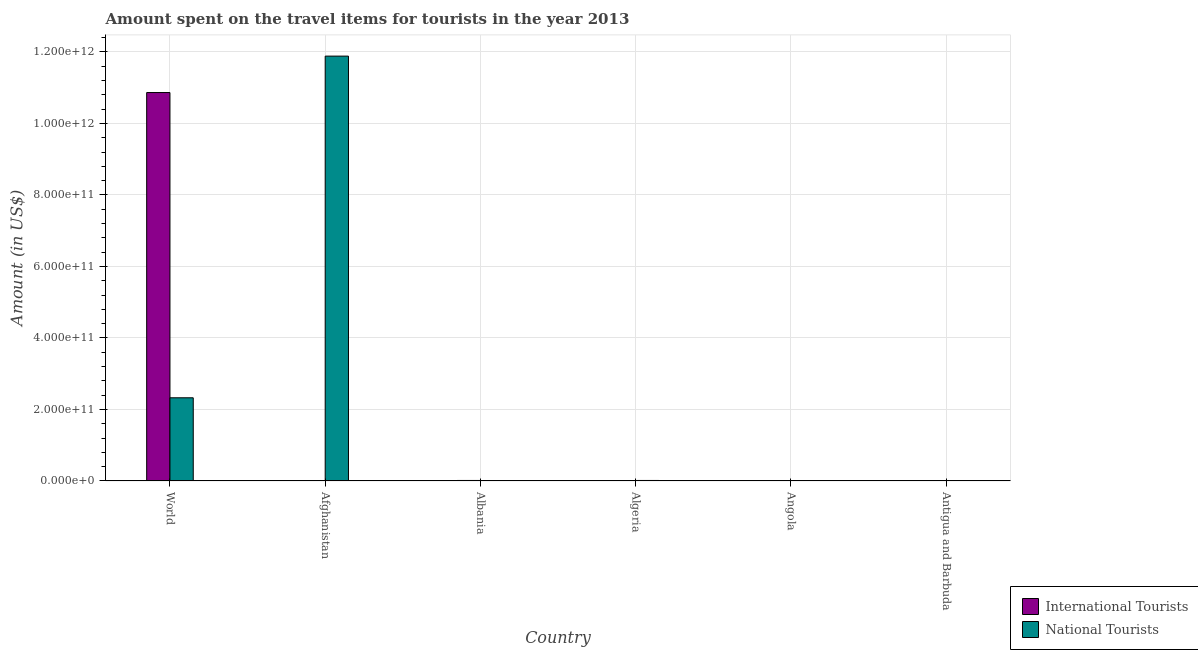How many different coloured bars are there?
Your answer should be compact. 2. How many groups of bars are there?
Offer a very short reply. 6. Are the number of bars per tick equal to the number of legend labels?
Keep it short and to the point. Yes. Are the number of bars on each tick of the X-axis equal?
Provide a succinct answer. Yes. How many bars are there on the 6th tick from the left?
Ensure brevity in your answer.  2. How many bars are there on the 5th tick from the right?
Keep it short and to the point. 2. What is the label of the 1st group of bars from the left?
Provide a succinct answer. World. In how many cases, is the number of bars for a given country not equal to the number of legend labels?
Ensure brevity in your answer.  0. What is the amount spent on travel items of national tourists in Antigua and Barbuda?
Offer a terse response. 1.23e+09. Across all countries, what is the maximum amount spent on travel items of national tourists?
Give a very brief answer. 1.19e+12. In which country was the amount spent on travel items of national tourists maximum?
Give a very brief answer. Afghanistan. In which country was the amount spent on travel items of international tourists minimum?
Your answer should be compact. Antigua and Barbuda. What is the total amount spent on travel items of international tourists in the graph?
Your response must be concise. 1.09e+12. What is the difference between the amount spent on travel items of national tourists in Algeria and that in World?
Provide a succinct answer. -2.31e+11. What is the difference between the amount spent on travel items of international tourists in Afghanistan and the amount spent on travel items of national tourists in Angola?
Keep it short and to the point. -1.56e+08. What is the average amount spent on travel items of international tourists per country?
Your response must be concise. 1.81e+11. What is the difference between the amount spent on travel items of international tourists and amount spent on travel items of national tourists in Algeria?
Provide a succinct answer. -1.05e+09. What is the ratio of the amount spent on travel items of international tourists in Albania to that in Antigua and Barbuda?
Offer a terse response. 29.58. Is the difference between the amount spent on travel items of international tourists in Algeria and Angola greater than the difference between the amount spent on travel items of national tourists in Algeria and Angola?
Offer a terse response. No. What is the difference between the highest and the second highest amount spent on travel items of international tourists?
Your answer should be very brief. 1.08e+12. What is the difference between the highest and the lowest amount spent on travel items of national tourists?
Provide a short and direct response. 1.19e+12. In how many countries, is the amount spent on travel items of international tourists greater than the average amount spent on travel items of international tourists taken over all countries?
Offer a terse response. 1. Is the sum of the amount spent on travel items of international tourists in Afghanistan and Antigua and Barbuda greater than the maximum amount spent on travel items of national tourists across all countries?
Your response must be concise. No. What does the 2nd bar from the left in Afghanistan represents?
Make the answer very short. National Tourists. What does the 1st bar from the right in Antigua and Barbuda represents?
Your response must be concise. National Tourists. How many bars are there?
Keep it short and to the point. 12. What is the difference between two consecutive major ticks on the Y-axis?
Give a very brief answer. 2.00e+11. Are the values on the major ticks of Y-axis written in scientific E-notation?
Keep it short and to the point. Yes. Does the graph contain grids?
Provide a succinct answer. Yes. What is the title of the graph?
Provide a succinct answer. Amount spent on the travel items for tourists in the year 2013. What is the Amount (in US$) in International Tourists in World?
Offer a very short reply. 1.09e+12. What is the Amount (in US$) of National Tourists in World?
Your response must be concise. 2.33e+11. What is the Amount (in US$) of International Tourists in Afghanistan?
Offer a very short reply. 9.40e+07. What is the Amount (in US$) of National Tourists in Afghanistan?
Make the answer very short. 1.19e+12. What is the Amount (in US$) in International Tourists in Albania?
Offer a very short reply. 1.48e+09. What is the Amount (in US$) of National Tourists in Albania?
Provide a succinct answer. 5.60e+07. What is the Amount (in US$) of International Tourists in Algeria?
Provide a short and direct response. 4.22e+08. What is the Amount (in US$) of National Tourists in Algeria?
Your response must be concise. 1.47e+09. What is the Amount (in US$) of International Tourists in Angola?
Your response must be concise. 1.66e+08. What is the Amount (in US$) in National Tourists in Angola?
Provide a short and direct response. 2.50e+08. What is the Amount (in US$) of International Tourists in Antigua and Barbuda?
Your answer should be compact. 5.00e+07. What is the Amount (in US$) of National Tourists in Antigua and Barbuda?
Make the answer very short. 1.23e+09. Across all countries, what is the maximum Amount (in US$) in International Tourists?
Keep it short and to the point. 1.09e+12. Across all countries, what is the maximum Amount (in US$) in National Tourists?
Your answer should be compact. 1.19e+12. Across all countries, what is the minimum Amount (in US$) of National Tourists?
Provide a succinct answer. 5.60e+07. What is the total Amount (in US$) of International Tourists in the graph?
Ensure brevity in your answer.  1.09e+12. What is the total Amount (in US$) of National Tourists in the graph?
Your response must be concise. 1.42e+12. What is the difference between the Amount (in US$) of International Tourists in World and that in Afghanistan?
Your answer should be very brief. 1.09e+12. What is the difference between the Amount (in US$) of National Tourists in World and that in Afghanistan?
Ensure brevity in your answer.  -9.56e+11. What is the difference between the Amount (in US$) in International Tourists in World and that in Albania?
Provide a short and direct response. 1.08e+12. What is the difference between the Amount (in US$) in National Tourists in World and that in Albania?
Offer a terse response. 2.33e+11. What is the difference between the Amount (in US$) in International Tourists in World and that in Algeria?
Keep it short and to the point. 1.09e+12. What is the difference between the Amount (in US$) in National Tourists in World and that in Algeria?
Offer a terse response. 2.31e+11. What is the difference between the Amount (in US$) in International Tourists in World and that in Angola?
Your answer should be very brief. 1.09e+12. What is the difference between the Amount (in US$) in National Tourists in World and that in Angola?
Offer a very short reply. 2.32e+11. What is the difference between the Amount (in US$) of International Tourists in World and that in Antigua and Barbuda?
Offer a terse response. 1.09e+12. What is the difference between the Amount (in US$) of National Tourists in World and that in Antigua and Barbuda?
Provide a short and direct response. 2.31e+11. What is the difference between the Amount (in US$) in International Tourists in Afghanistan and that in Albania?
Provide a short and direct response. -1.38e+09. What is the difference between the Amount (in US$) in National Tourists in Afghanistan and that in Albania?
Provide a succinct answer. 1.19e+12. What is the difference between the Amount (in US$) of International Tourists in Afghanistan and that in Algeria?
Give a very brief answer. -3.28e+08. What is the difference between the Amount (in US$) in National Tourists in Afghanistan and that in Algeria?
Your response must be concise. 1.19e+12. What is the difference between the Amount (in US$) in International Tourists in Afghanistan and that in Angola?
Make the answer very short. -7.20e+07. What is the difference between the Amount (in US$) of National Tourists in Afghanistan and that in Angola?
Your answer should be compact. 1.19e+12. What is the difference between the Amount (in US$) in International Tourists in Afghanistan and that in Antigua and Barbuda?
Provide a succinct answer. 4.40e+07. What is the difference between the Amount (in US$) of National Tourists in Afghanistan and that in Antigua and Barbuda?
Ensure brevity in your answer.  1.19e+12. What is the difference between the Amount (in US$) of International Tourists in Albania and that in Algeria?
Provide a succinct answer. 1.06e+09. What is the difference between the Amount (in US$) in National Tourists in Albania and that in Algeria?
Ensure brevity in your answer.  -1.42e+09. What is the difference between the Amount (in US$) of International Tourists in Albania and that in Angola?
Ensure brevity in your answer.  1.31e+09. What is the difference between the Amount (in US$) in National Tourists in Albania and that in Angola?
Ensure brevity in your answer.  -1.94e+08. What is the difference between the Amount (in US$) in International Tourists in Albania and that in Antigua and Barbuda?
Offer a terse response. 1.43e+09. What is the difference between the Amount (in US$) in National Tourists in Albania and that in Antigua and Barbuda?
Give a very brief answer. -1.18e+09. What is the difference between the Amount (in US$) of International Tourists in Algeria and that in Angola?
Provide a succinct answer. 2.56e+08. What is the difference between the Amount (in US$) of National Tourists in Algeria and that in Angola?
Your answer should be very brief. 1.22e+09. What is the difference between the Amount (in US$) in International Tourists in Algeria and that in Antigua and Barbuda?
Your response must be concise. 3.72e+08. What is the difference between the Amount (in US$) in National Tourists in Algeria and that in Antigua and Barbuda?
Offer a very short reply. 2.39e+08. What is the difference between the Amount (in US$) in International Tourists in Angola and that in Antigua and Barbuda?
Give a very brief answer. 1.16e+08. What is the difference between the Amount (in US$) of National Tourists in Angola and that in Antigua and Barbuda?
Give a very brief answer. -9.84e+08. What is the difference between the Amount (in US$) in International Tourists in World and the Amount (in US$) in National Tourists in Afghanistan?
Offer a terse response. -1.02e+11. What is the difference between the Amount (in US$) of International Tourists in World and the Amount (in US$) of National Tourists in Albania?
Provide a short and direct response. 1.09e+12. What is the difference between the Amount (in US$) in International Tourists in World and the Amount (in US$) in National Tourists in Algeria?
Your answer should be compact. 1.08e+12. What is the difference between the Amount (in US$) in International Tourists in World and the Amount (in US$) in National Tourists in Angola?
Offer a very short reply. 1.09e+12. What is the difference between the Amount (in US$) of International Tourists in World and the Amount (in US$) of National Tourists in Antigua and Barbuda?
Provide a succinct answer. 1.09e+12. What is the difference between the Amount (in US$) in International Tourists in Afghanistan and the Amount (in US$) in National Tourists in Albania?
Your response must be concise. 3.80e+07. What is the difference between the Amount (in US$) in International Tourists in Afghanistan and the Amount (in US$) in National Tourists in Algeria?
Your answer should be very brief. -1.38e+09. What is the difference between the Amount (in US$) in International Tourists in Afghanistan and the Amount (in US$) in National Tourists in Angola?
Ensure brevity in your answer.  -1.56e+08. What is the difference between the Amount (in US$) of International Tourists in Afghanistan and the Amount (in US$) of National Tourists in Antigua and Barbuda?
Provide a short and direct response. -1.14e+09. What is the difference between the Amount (in US$) in International Tourists in Albania and the Amount (in US$) in National Tourists in Algeria?
Keep it short and to the point. 6.00e+06. What is the difference between the Amount (in US$) in International Tourists in Albania and the Amount (in US$) in National Tourists in Angola?
Offer a very short reply. 1.23e+09. What is the difference between the Amount (in US$) of International Tourists in Albania and the Amount (in US$) of National Tourists in Antigua and Barbuda?
Provide a short and direct response. 2.45e+08. What is the difference between the Amount (in US$) of International Tourists in Algeria and the Amount (in US$) of National Tourists in Angola?
Your answer should be compact. 1.72e+08. What is the difference between the Amount (in US$) in International Tourists in Algeria and the Amount (in US$) in National Tourists in Antigua and Barbuda?
Provide a succinct answer. -8.12e+08. What is the difference between the Amount (in US$) of International Tourists in Angola and the Amount (in US$) of National Tourists in Antigua and Barbuda?
Offer a terse response. -1.07e+09. What is the average Amount (in US$) in International Tourists per country?
Your response must be concise. 1.81e+11. What is the average Amount (in US$) of National Tourists per country?
Make the answer very short. 2.37e+11. What is the difference between the Amount (in US$) of International Tourists and Amount (in US$) of National Tourists in World?
Make the answer very short. 8.54e+11. What is the difference between the Amount (in US$) in International Tourists and Amount (in US$) in National Tourists in Afghanistan?
Your response must be concise. -1.19e+12. What is the difference between the Amount (in US$) of International Tourists and Amount (in US$) of National Tourists in Albania?
Your response must be concise. 1.42e+09. What is the difference between the Amount (in US$) of International Tourists and Amount (in US$) of National Tourists in Algeria?
Your answer should be very brief. -1.05e+09. What is the difference between the Amount (in US$) of International Tourists and Amount (in US$) of National Tourists in Angola?
Provide a succinct answer. -8.40e+07. What is the difference between the Amount (in US$) of International Tourists and Amount (in US$) of National Tourists in Antigua and Barbuda?
Your response must be concise. -1.18e+09. What is the ratio of the Amount (in US$) of International Tourists in World to that in Afghanistan?
Provide a succinct answer. 1.16e+04. What is the ratio of the Amount (in US$) of National Tourists in World to that in Afghanistan?
Your answer should be very brief. 0.2. What is the ratio of the Amount (in US$) of International Tourists in World to that in Albania?
Your response must be concise. 734.58. What is the ratio of the Amount (in US$) of National Tourists in World to that in Albania?
Offer a terse response. 4155.84. What is the ratio of the Amount (in US$) in International Tourists in World to that in Algeria?
Offer a terse response. 2574.5. What is the ratio of the Amount (in US$) of National Tourists in World to that in Algeria?
Offer a very short reply. 158. What is the ratio of the Amount (in US$) in International Tourists in World to that in Angola?
Offer a very short reply. 6544.82. What is the ratio of the Amount (in US$) in National Tourists in World to that in Angola?
Offer a very short reply. 930.91. What is the ratio of the Amount (in US$) in International Tourists in World to that in Antigua and Barbuda?
Make the answer very short. 2.17e+04. What is the ratio of the Amount (in US$) in National Tourists in World to that in Antigua and Barbuda?
Provide a succinct answer. 188.6. What is the ratio of the Amount (in US$) in International Tourists in Afghanistan to that in Albania?
Provide a short and direct response. 0.06. What is the ratio of the Amount (in US$) of National Tourists in Afghanistan to that in Albania?
Offer a very short reply. 2.12e+04. What is the ratio of the Amount (in US$) of International Tourists in Afghanistan to that in Algeria?
Provide a short and direct response. 0.22. What is the ratio of the Amount (in US$) of National Tourists in Afghanistan to that in Algeria?
Your answer should be compact. 806.72. What is the ratio of the Amount (in US$) of International Tourists in Afghanistan to that in Angola?
Offer a very short reply. 0.57. What is the ratio of the Amount (in US$) in National Tourists in Afghanistan to that in Angola?
Your answer should be compact. 4753.17. What is the ratio of the Amount (in US$) in International Tourists in Afghanistan to that in Antigua and Barbuda?
Make the answer very short. 1.88. What is the ratio of the Amount (in US$) of National Tourists in Afghanistan to that in Antigua and Barbuda?
Offer a very short reply. 962.96. What is the ratio of the Amount (in US$) in International Tourists in Albania to that in Algeria?
Offer a terse response. 3.5. What is the ratio of the Amount (in US$) in National Tourists in Albania to that in Algeria?
Provide a succinct answer. 0.04. What is the ratio of the Amount (in US$) in International Tourists in Albania to that in Angola?
Provide a short and direct response. 8.91. What is the ratio of the Amount (in US$) in National Tourists in Albania to that in Angola?
Ensure brevity in your answer.  0.22. What is the ratio of the Amount (in US$) of International Tourists in Albania to that in Antigua and Barbuda?
Your answer should be very brief. 29.58. What is the ratio of the Amount (in US$) in National Tourists in Albania to that in Antigua and Barbuda?
Offer a very short reply. 0.05. What is the ratio of the Amount (in US$) of International Tourists in Algeria to that in Angola?
Give a very brief answer. 2.54. What is the ratio of the Amount (in US$) of National Tourists in Algeria to that in Angola?
Offer a very short reply. 5.89. What is the ratio of the Amount (in US$) of International Tourists in Algeria to that in Antigua and Barbuda?
Provide a succinct answer. 8.44. What is the ratio of the Amount (in US$) of National Tourists in Algeria to that in Antigua and Barbuda?
Offer a very short reply. 1.19. What is the ratio of the Amount (in US$) in International Tourists in Angola to that in Antigua and Barbuda?
Your answer should be very brief. 3.32. What is the ratio of the Amount (in US$) of National Tourists in Angola to that in Antigua and Barbuda?
Your answer should be very brief. 0.2. What is the difference between the highest and the second highest Amount (in US$) of International Tourists?
Provide a succinct answer. 1.08e+12. What is the difference between the highest and the second highest Amount (in US$) of National Tourists?
Your response must be concise. 9.56e+11. What is the difference between the highest and the lowest Amount (in US$) in International Tourists?
Make the answer very short. 1.09e+12. What is the difference between the highest and the lowest Amount (in US$) of National Tourists?
Provide a short and direct response. 1.19e+12. 